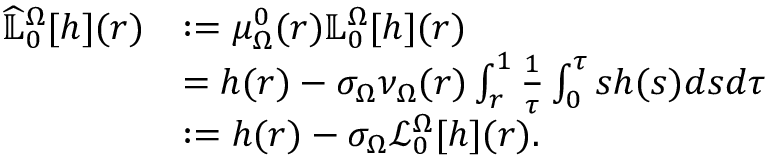Convert formula to latex. <formula><loc_0><loc_0><loc_500><loc_500>\begin{array} { r l } { \widehat { \mathbb { L } } _ { 0 } ^ { \Omega } [ h ] ( r ) } & { \colon = \mu _ { \Omega } ^ { 0 } ( r ) \mathbb { L } _ { 0 } ^ { \Omega } [ h ] ( r ) } \\ & { = { h ( r ) } - \sigma _ { \Omega } { \nu _ { \Omega } ( r ) } \int _ { r } ^ { 1 } \frac { 1 } { \tau } \int _ { 0 } ^ { \tau } s h ( s ) d s d \tau } \\ & { \colon = { h ( r ) } - \sigma _ { \Omega } \mathcal { L } _ { 0 } ^ { \Omega } [ h ] ( r ) . } \end{array}</formula> 